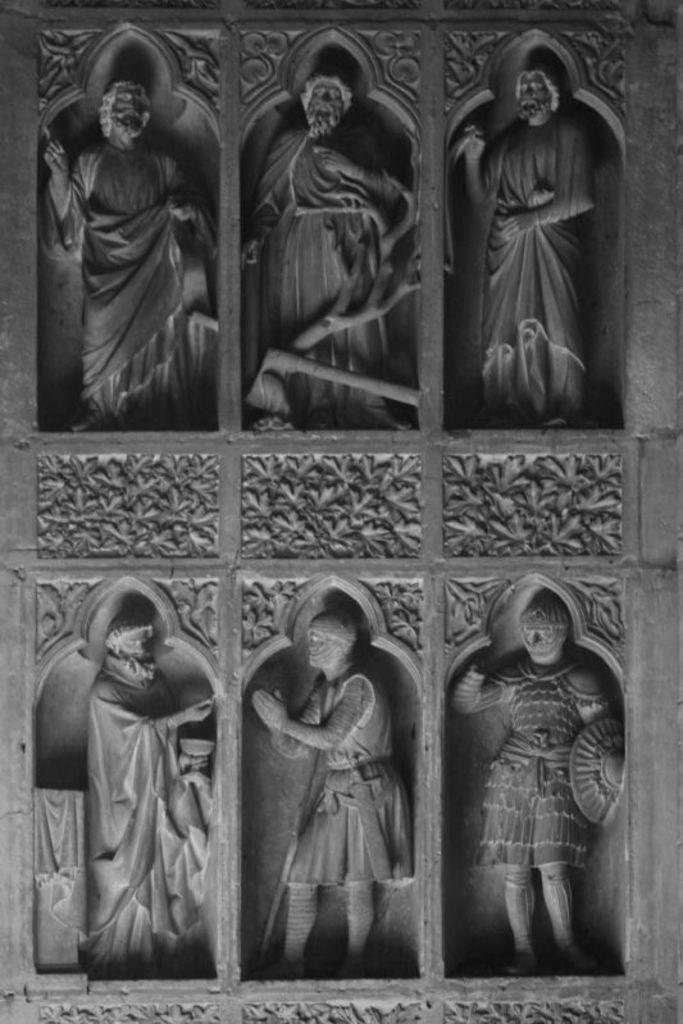What is present on the wall in the image? There are six sculptures on the wall in the image. Is there any additional design or pattern on the wall? Yes, there is a design on the wall. Are there any recesses in the wall where the sculptures are placed? There is no mention of recesses in the image, so it cannot be determined if they are present. Can you see any cobwebs on the sculptures or the wall? There is no mention of cobwebs in the image, so it cannot be determined if they are present. 